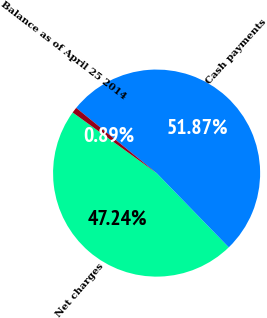Convert chart. <chart><loc_0><loc_0><loc_500><loc_500><pie_chart><fcel>Net charges<fcel>Cash payments<fcel>Balance as of April 25 2014<nl><fcel>47.24%<fcel>51.88%<fcel>0.89%<nl></chart> 